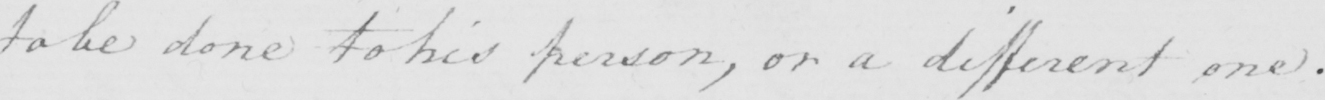What is written in this line of handwriting? to be done to his person , or a different one . 